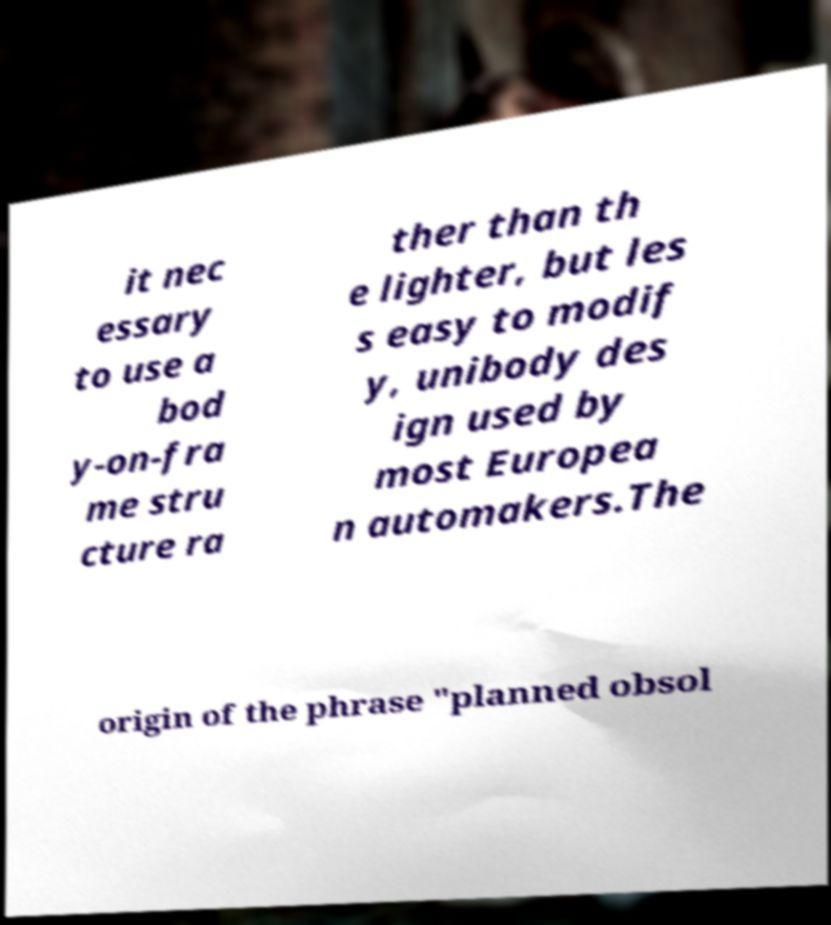Can you read and provide the text displayed in the image?This photo seems to have some interesting text. Can you extract and type it out for me? it nec essary to use a bod y-on-fra me stru cture ra ther than th e lighter, but les s easy to modif y, unibody des ign used by most Europea n automakers.The origin of the phrase "planned obsol 